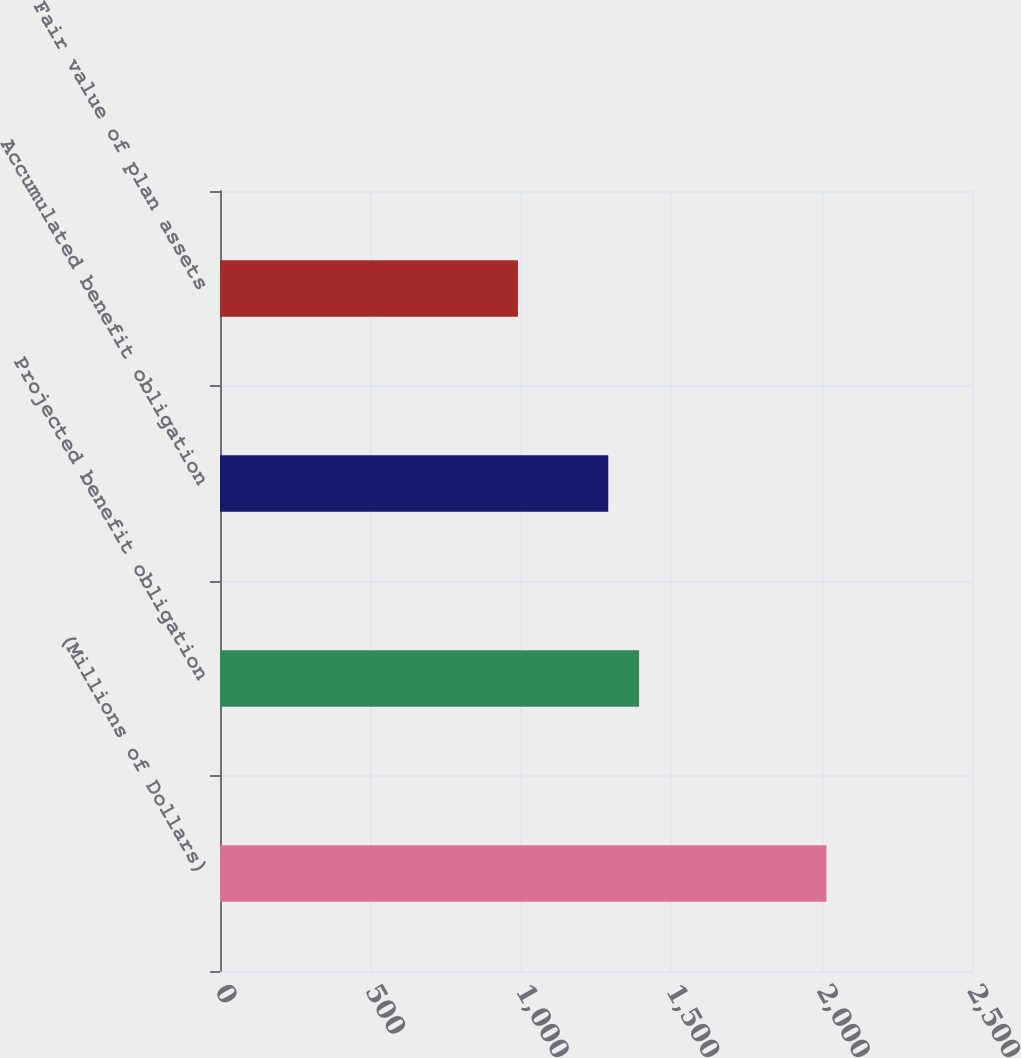<chart> <loc_0><loc_0><loc_500><loc_500><bar_chart><fcel>(Millions of Dollars)<fcel>Projected benefit obligation<fcel>Accumulated benefit obligation<fcel>Fair value of plan assets<nl><fcel>2016<fcel>1393.25<fcel>1290.7<fcel>990.5<nl></chart> 